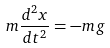<formula> <loc_0><loc_0><loc_500><loc_500>m \frac { d ^ { 2 } x } { d t ^ { 2 } } = - m g</formula> 